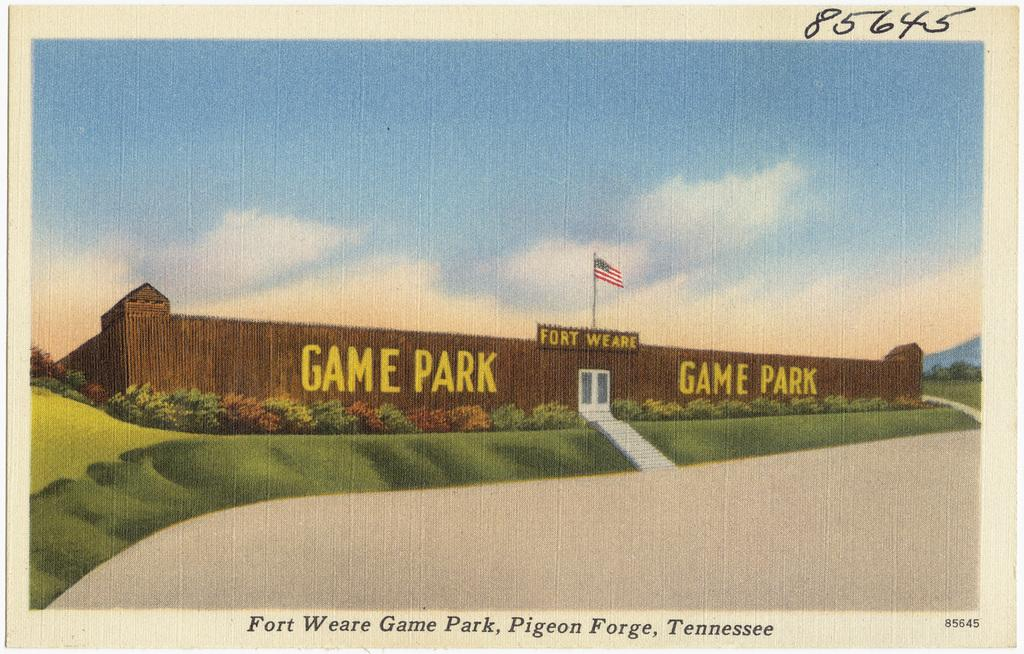What type of image is being described? The image is animated. What is the main subject in the middle of the image? There is a game park in the middle of the image. What can be seen in the game park? There is a flag in the game park. What color is the sky in the image? The sky is blue in color. How many jellyfish can be seen swimming in the game park? There are no jellyfish present in the game park; it is a land-based area. Are there any deer visible in the game park? There is no mention of deer in the provided facts, so we cannot determine their presence in the game park. 